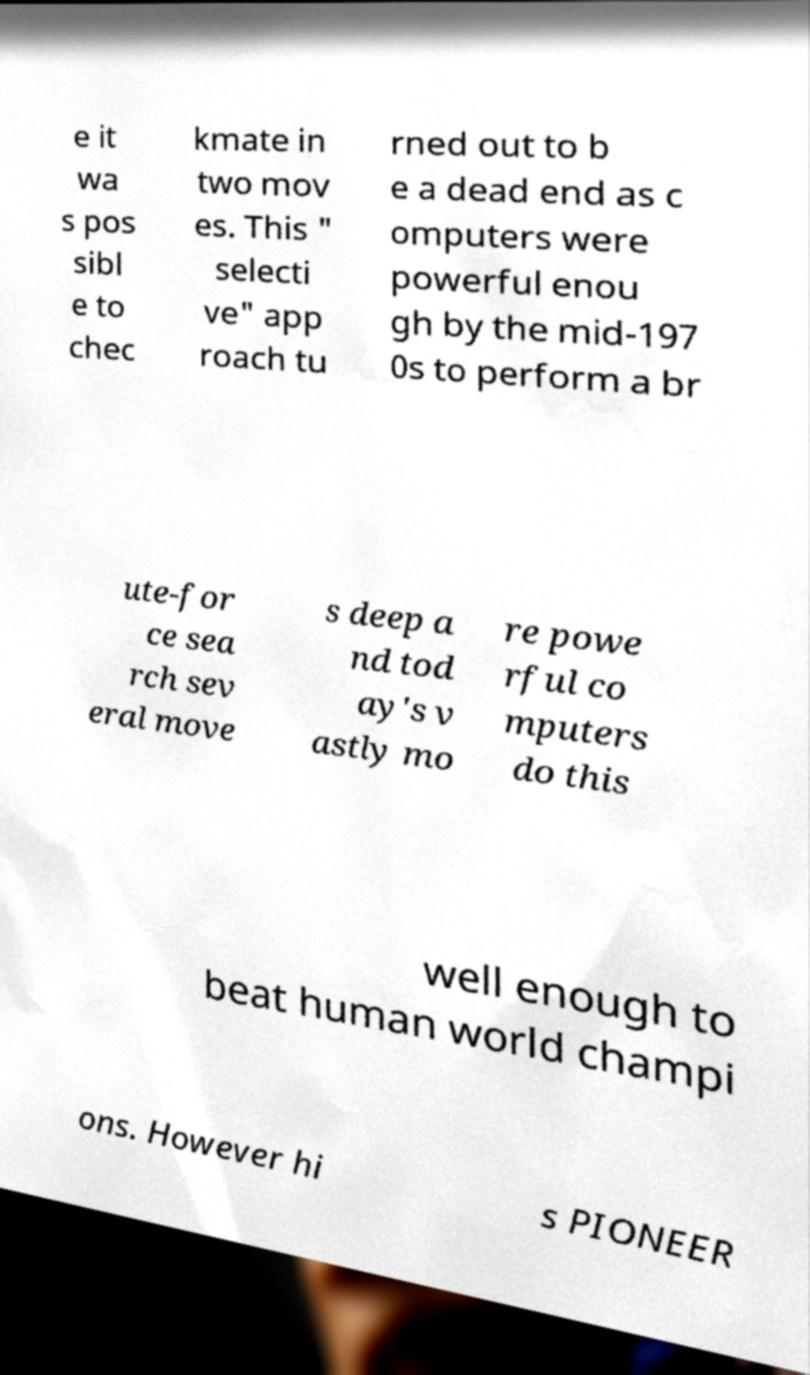Can you accurately transcribe the text from the provided image for me? e it wa s pos sibl e to chec kmate in two mov es. This " selecti ve" app roach tu rned out to b e a dead end as c omputers were powerful enou gh by the mid-197 0s to perform a br ute-for ce sea rch sev eral move s deep a nd tod ay's v astly mo re powe rful co mputers do this well enough to beat human world champi ons. However hi s PIONEER 